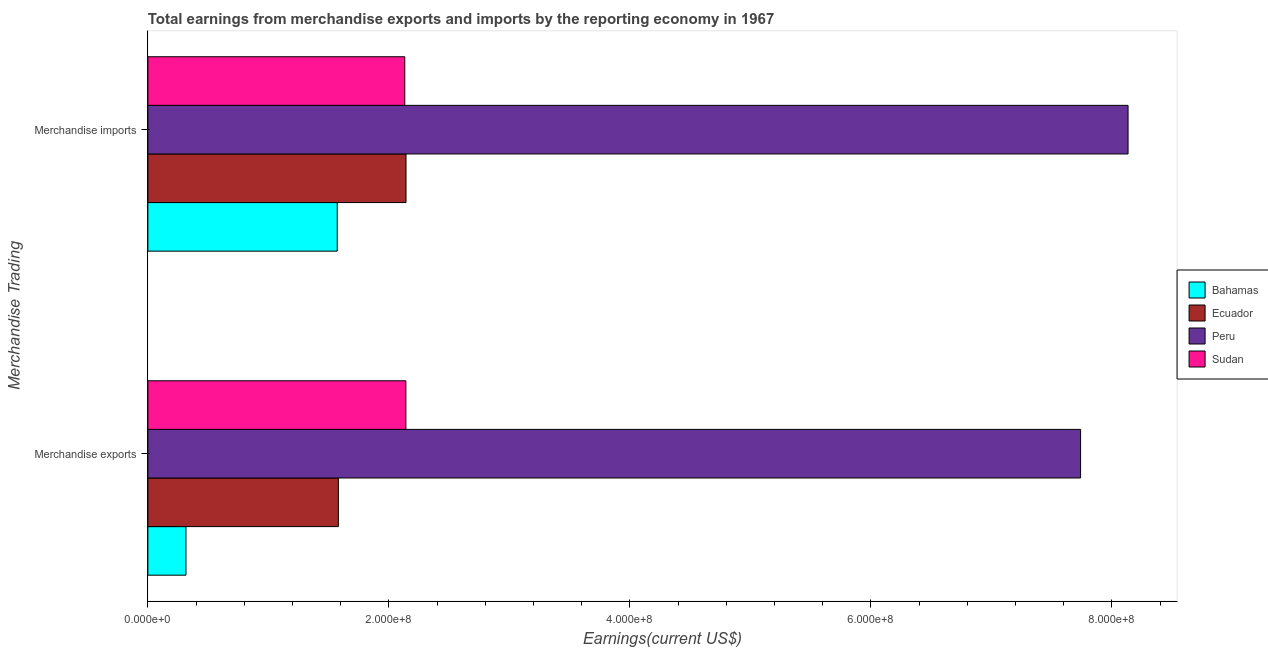Are the number of bars on each tick of the Y-axis equal?
Offer a terse response. Yes. How many bars are there on the 2nd tick from the top?
Provide a short and direct response. 4. How many bars are there on the 2nd tick from the bottom?
Your response must be concise. 4. What is the earnings from merchandise exports in Ecuador?
Provide a short and direct response. 1.58e+08. Across all countries, what is the maximum earnings from merchandise exports?
Offer a terse response. 7.74e+08. Across all countries, what is the minimum earnings from merchandise exports?
Offer a very short reply. 3.16e+07. In which country was the earnings from merchandise imports maximum?
Your answer should be very brief. Peru. In which country was the earnings from merchandise imports minimum?
Offer a terse response. Bahamas. What is the total earnings from merchandise imports in the graph?
Make the answer very short. 1.40e+09. What is the difference between the earnings from merchandise imports in Bahamas and that in Sudan?
Ensure brevity in your answer.  -5.61e+07. What is the difference between the earnings from merchandise exports in Sudan and the earnings from merchandise imports in Ecuador?
Keep it short and to the point. -1.20e+05. What is the average earnings from merchandise imports per country?
Provide a short and direct response. 3.49e+08. What is the difference between the earnings from merchandise imports and earnings from merchandise exports in Peru?
Provide a short and direct response. 3.94e+07. What is the ratio of the earnings from merchandise imports in Ecuador to that in Peru?
Your response must be concise. 0.26. In how many countries, is the earnings from merchandise imports greater than the average earnings from merchandise imports taken over all countries?
Provide a short and direct response. 1. What does the 4th bar from the top in Merchandise exports represents?
Give a very brief answer. Bahamas. What does the 2nd bar from the bottom in Merchandise exports represents?
Your response must be concise. Ecuador. Are all the bars in the graph horizontal?
Provide a succinct answer. Yes. How many countries are there in the graph?
Offer a very short reply. 4. What is the difference between two consecutive major ticks on the X-axis?
Ensure brevity in your answer.  2.00e+08. Where does the legend appear in the graph?
Provide a succinct answer. Center right. How are the legend labels stacked?
Provide a succinct answer. Vertical. What is the title of the graph?
Give a very brief answer. Total earnings from merchandise exports and imports by the reporting economy in 1967. What is the label or title of the X-axis?
Ensure brevity in your answer.  Earnings(current US$). What is the label or title of the Y-axis?
Offer a terse response. Merchandise Trading. What is the Earnings(current US$) of Bahamas in Merchandise exports?
Offer a terse response. 3.16e+07. What is the Earnings(current US$) of Ecuador in Merchandise exports?
Make the answer very short. 1.58e+08. What is the Earnings(current US$) of Peru in Merchandise exports?
Provide a short and direct response. 7.74e+08. What is the Earnings(current US$) in Sudan in Merchandise exports?
Offer a very short reply. 2.14e+08. What is the Earnings(current US$) in Bahamas in Merchandise imports?
Your response must be concise. 1.57e+08. What is the Earnings(current US$) in Ecuador in Merchandise imports?
Offer a terse response. 2.14e+08. What is the Earnings(current US$) of Peru in Merchandise imports?
Give a very brief answer. 8.13e+08. What is the Earnings(current US$) in Sudan in Merchandise imports?
Offer a very short reply. 2.13e+08. Across all Merchandise Trading, what is the maximum Earnings(current US$) of Bahamas?
Give a very brief answer. 1.57e+08. Across all Merchandise Trading, what is the maximum Earnings(current US$) of Ecuador?
Give a very brief answer. 2.14e+08. Across all Merchandise Trading, what is the maximum Earnings(current US$) in Peru?
Your answer should be very brief. 8.13e+08. Across all Merchandise Trading, what is the maximum Earnings(current US$) in Sudan?
Your answer should be very brief. 2.14e+08. Across all Merchandise Trading, what is the minimum Earnings(current US$) in Bahamas?
Provide a short and direct response. 3.16e+07. Across all Merchandise Trading, what is the minimum Earnings(current US$) in Ecuador?
Offer a very short reply. 1.58e+08. Across all Merchandise Trading, what is the minimum Earnings(current US$) of Peru?
Offer a very short reply. 7.74e+08. Across all Merchandise Trading, what is the minimum Earnings(current US$) in Sudan?
Ensure brevity in your answer.  2.13e+08. What is the total Earnings(current US$) in Bahamas in the graph?
Give a very brief answer. 1.89e+08. What is the total Earnings(current US$) of Ecuador in the graph?
Make the answer very short. 3.72e+08. What is the total Earnings(current US$) in Peru in the graph?
Offer a terse response. 1.59e+09. What is the total Earnings(current US$) of Sudan in the graph?
Your response must be concise. 4.27e+08. What is the difference between the Earnings(current US$) of Bahamas in Merchandise exports and that in Merchandise imports?
Your answer should be compact. -1.26e+08. What is the difference between the Earnings(current US$) of Ecuador in Merchandise exports and that in Merchandise imports?
Offer a very short reply. -5.61e+07. What is the difference between the Earnings(current US$) of Peru in Merchandise exports and that in Merchandise imports?
Ensure brevity in your answer.  -3.94e+07. What is the difference between the Earnings(current US$) in Sudan in Merchandise exports and that in Merchandise imports?
Give a very brief answer. 9.00e+05. What is the difference between the Earnings(current US$) of Bahamas in Merchandise exports and the Earnings(current US$) of Ecuador in Merchandise imports?
Provide a short and direct response. -1.83e+08. What is the difference between the Earnings(current US$) in Bahamas in Merchandise exports and the Earnings(current US$) in Peru in Merchandise imports?
Your response must be concise. -7.82e+08. What is the difference between the Earnings(current US$) of Bahamas in Merchandise exports and the Earnings(current US$) of Sudan in Merchandise imports?
Provide a succinct answer. -1.82e+08. What is the difference between the Earnings(current US$) in Ecuador in Merchandise exports and the Earnings(current US$) in Peru in Merchandise imports?
Provide a succinct answer. -6.55e+08. What is the difference between the Earnings(current US$) in Ecuador in Merchandise exports and the Earnings(current US$) in Sudan in Merchandise imports?
Your response must be concise. -5.51e+07. What is the difference between the Earnings(current US$) in Peru in Merchandise exports and the Earnings(current US$) in Sudan in Merchandise imports?
Your response must be concise. 5.61e+08. What is the average Earnings(current US$) in Bahamas per Merchandise Trading?
Your answer should be very brief. 9.44e+07. What is the average Earnings(current US$) of Ecuador per Merchandise Trading?
Your answer should be compact. 1.86e+08. What is the average Earnings(current US$) in Peru per Merchandise Trading?
Offer a very short reply. 7.94e+08. What is the average Earnings(current US$) of Sudan per Merchandise Trading?
Provide a short and direct response. 2.14e+08. What is the difference between the Earnings(current US$) in Bahamas and Earnings(current US$) in Ecuador in Merchandise exports?
Give a very brief answer. -1.26e+08. What is the difference between the Earnings(current US$) in Bahamas and Earnings(current US$) in Peru in Merchandise exports?
Make the answer very short. -7.42e+08. What is the difference between the Earnings(current US$) in Bahamas and Earnings(current US$) in Sudan in Merchandise exports?
Offer a very short reply. -1.82e+08. What is the difference between the Earnings(current US$) of Ecuador and Earnings(current US$) of Peru in Merchandise exports?
Provide a short and direct response. -6.16e+08. What is the difference between the Earnings(current US$) of Ecuador and Earnings(current US$) of Sudan in Merchandise exports?
Offer a very short reply. -5.60e+07. What is the difference between the Earnings(current US$) of Peru and Earnings(current US$) of Sudan in Merchandise exports?
Offer a very short reply. 5.60e+08. What is the difference between the Earnings(current US$) of Bahamas and Earnings(current US$) of Ecuador in Merchandise imports?
Offer a terse response. -5.71e+07. What is the difference between the Earnings(current US$) in Bahamas and Earnings(current US$) in Peru in Merchandise imports?
Give a very brief answer. -6.56e+08. What is the difference between the Earnings(current US$) of Bahamas and Earnings(current US$) of Sudan in Merchandise imports?
Offer a terse response. -5.61e+07. What is the difference between the Earnings(current US$) in Ecuador and Earnings(current US$) in Peru in Merchandise imports?
Your answer should be very brief. -5.99e+08. What is the difference between the Earnings(current US$) in Ecuador and Earnings(current US$) in Sudan in Merchandise imports?
Make the answer very short. 1.02e+06. What is the difference between the Earnings(current US$) in Peru and Earnings(current US$) in Sudan in Merchandise imports?
Provide a succinct answer. 6.00e+08. What is the ratio of the Earnings(current US$) of Bahamas in Merchandise exports to that in Merchandise imports?
Offer a very short reply. 0.2. What is the ratio of the Earnings(current US$) in Ecuador in Merchandise exports to that in Merchandise imports?
Offer a terse response. 0.74. What is the ratio of the Earnings(current US$) in Peru in Merchandise exports to that in Merchandise imports?
Your answer should be compact. 0.95. What is the ratio of the Earnings(current US$) in Sudan in Merchandise exports to that in Merchandise imports?
Give a very brief answer. 1. What is the difference between the highest and the second highest Earnings(current US$) in Bahamas?
Make the answer very short. 1.26e+08. What is the difference between the highest and the second highest Earnings(current US$) in Ecuador?
Your response must be concise. 5.61e+07. What is the difference between the highest and the second highest Earnings(current US$) of Peru?
Keep it short and to the point. 3.94e+07. What is the difference between the highest and the lowest Earnings(current US$) in Bahamas?
Provide a short and direct response. 1.26e+08. What is the difference between the highest and the lowest Earnings(current US$) in Ecuador?
Provide a succinct answer. 5.61e+07. What is the difference between the highest and the lowest Earnings(current US$) in Peru?
Keep it short and to the point. 3.94e+07. What is the difference between the highest and the lowest Earnings(current US$) of Sudan?
Provide a succinct answer. 9.00e+05. 